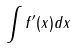Convert formula to latex. <formula><loc_0><loc_0><loc_500><loc_500>\int f ^ { \prime } ( x ) d x</formula> 